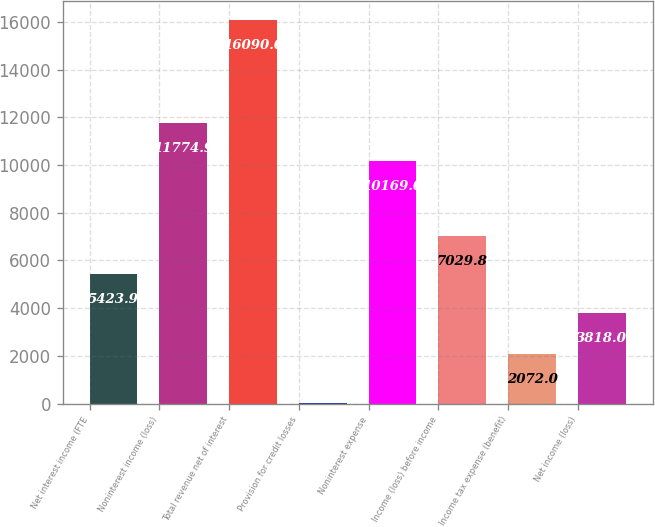Convert chart. <chart><loc_0><loc_0><loc_500><loc_500><bar_chart><fcel>Net interest income (FTE<fcel>Noninterest income (loss)<fcel>Total revenue net of interest<fcel>Provision for credit losses<fcel>Noninterest expense<fcel>Income (loss) before income<fcel>Income tax expense (benefit)<fcel>Net income (loss)<nl><fcel>5423.9<fcel>11774.9<fcel>16090<fcel>31<fcel>10169<fcel>7029.8<fcel>2072<fcel>3818<nl></chart> 